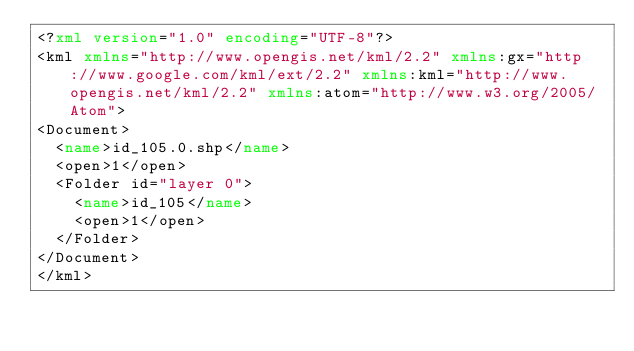Convert code to text. <code><loc_0><loc_0><loc_500><loc_500><_XML_><?xml version="1.0" encoding="UTF-8"?>
<kml xmlns="http://www.opengis.net/kml/2.2" xmlns:gx="http://www.google.com/kml/ext/2.2" xmlns:kml="http://www.opengis.net/kml/2.2" xmlns:atom="http://www.w3.org/2005/Atom">
<Document>
	<name>id_105.0.shp</name>
	<open>1</open>
	<Folder id="layer 0">
		<name>id_105</name>
		<open>1</open>
	</Folder>
</Document>
</kml>
</code> 